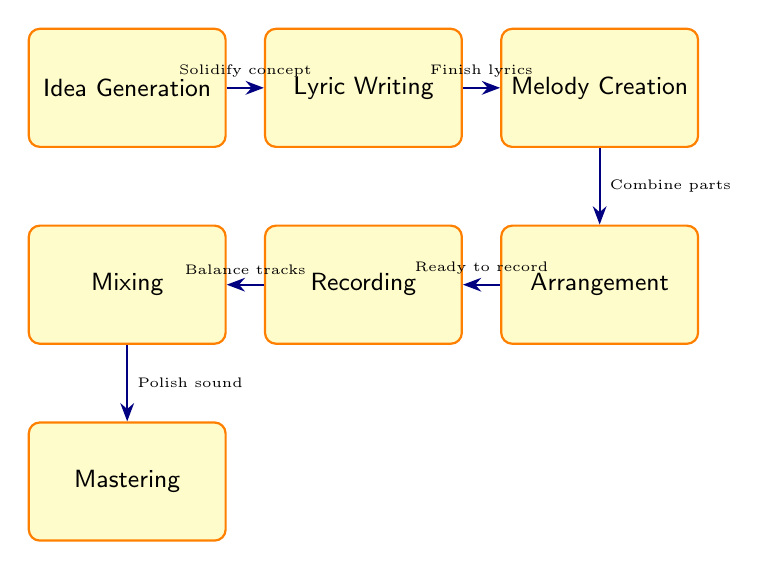What is the final state in this workflow? The final state in the workflow is "Mastering," which represents the last step after all preceding processes have been completed.
Answer: Mastering How many states are present in this diagram? The diagram lists a total of 7 states that represent different phases in the song composition workflow.
Answer: 7 What is the state that follows "Lyric Writing"? After "Lyric Writing," the next state is "Melody Creation," as indicated by the transition leading from writing lyrics to creating the melody.
Answer: Melody Creation What description corresponds to the state "Recording"? The state "Recording" is described as "Laying down tracks in the recording studio," detailing what happens in this phase of the workflow.
Answer: Laying down tracks in the recording studio What transition description is associated with moving from "Melody Creation" to "Arrangement"? The transition associated with moving from "Melody Creation" to "Arrangement" is "Combining lyrics and melodies into structured parts of the song," which summarizes this step.
Answer: Combining lyrics and melodies into structured parts of the song What is the relationship between "Mixing" and "Mastering"? The relationship is that "Mixing" transitions to "Mastering," with the description explaining that mixed tracks require final polishing through mastering before distribution.
Answer: Mixed tracks require final polishing through mastering In which state does the process start? The process starts in the state called "Idea Generation," where the initial song concepts are brainstormed.
Answer: Idea Generation 